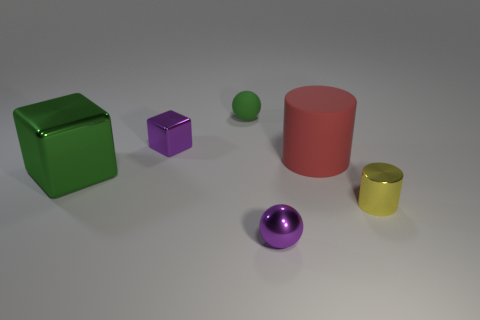Add 1 small green shiny cylinders. How many objects exist? 7 Subtract all balls. How many objects are left? 4 Subtract all green objects. Subtract all tiny purple shiny spheres. How many objects are left? 3 Add 2 purple balls. How many purple balls are left? 3 Add 4 large brown rubber objects. How many large brown rubber objects exist? 4 Subtract 0 cyan cubes. How many objects are left? 6 